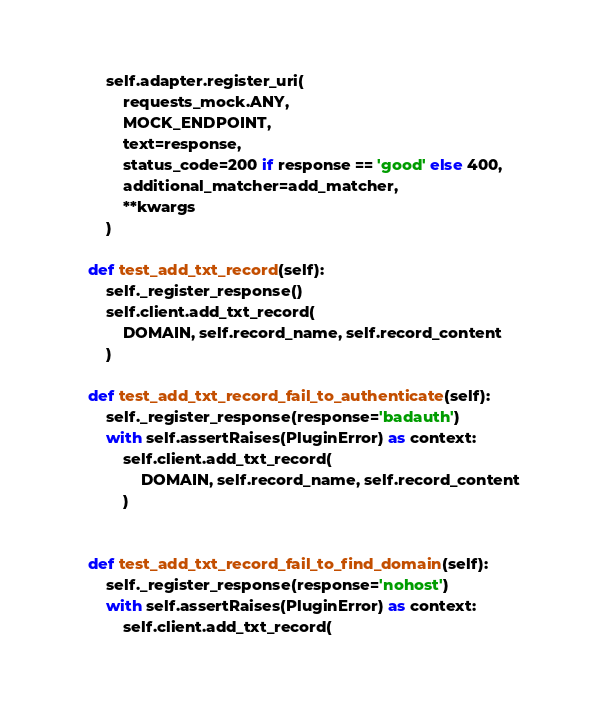<code> <loc_0><loc_0><loc_500><loc_500><_Python_>
        self.adapter.register_uri(
            requests_mock.ANY,
            MOCK_ENDPOINT,
            text=response,
            status_code=200 if response == 'good' else 400,
            additional_matcher=add_matcher,
            **kwargs
        )

    def test_add_txt_record(self):
        self._register_response()
        self.client.add_txt_record(
            DOMAIN, self.record_name, self.record_content
        )

    def test_add_txt_record_fail_to_authenticate(self):
        self._register_response(response='badauth')
        with self.assertRaises(PluginError) as context:
            self.client.add_txt_record(
                DOMAIN, self.record_name, self.record_content
            )


    def test_add_txt_record_fail_to_find_domain(self):
        self._register_response(response='nohost')
        with self.assertRaises(PluginError) as context:
            self.client.add_txt_record(</code> 